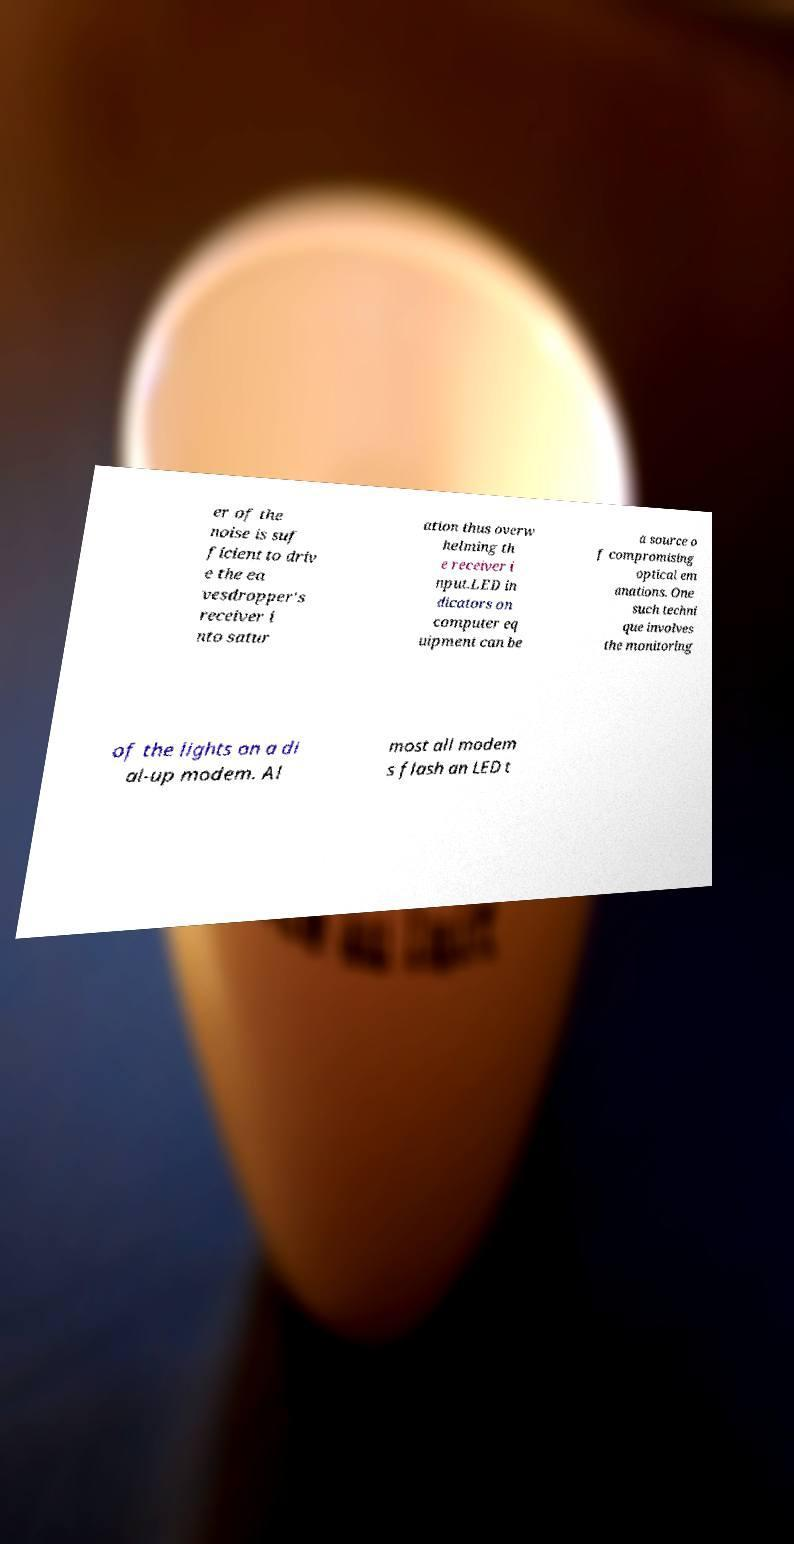There's text embedded in this image that I need extracted. Can you transcribe it verbatim? er of the noise is suf ficient to driv e the ea vesdropper's receiver i nto satur ation thus overw helming th e receiver i nput.LED in dicators on computer eq uipment can be a source o f compromising optical em anations. One such techni que involves the monitoring of the lights on a di al-up modem. Al most all modem s flash an LED t 